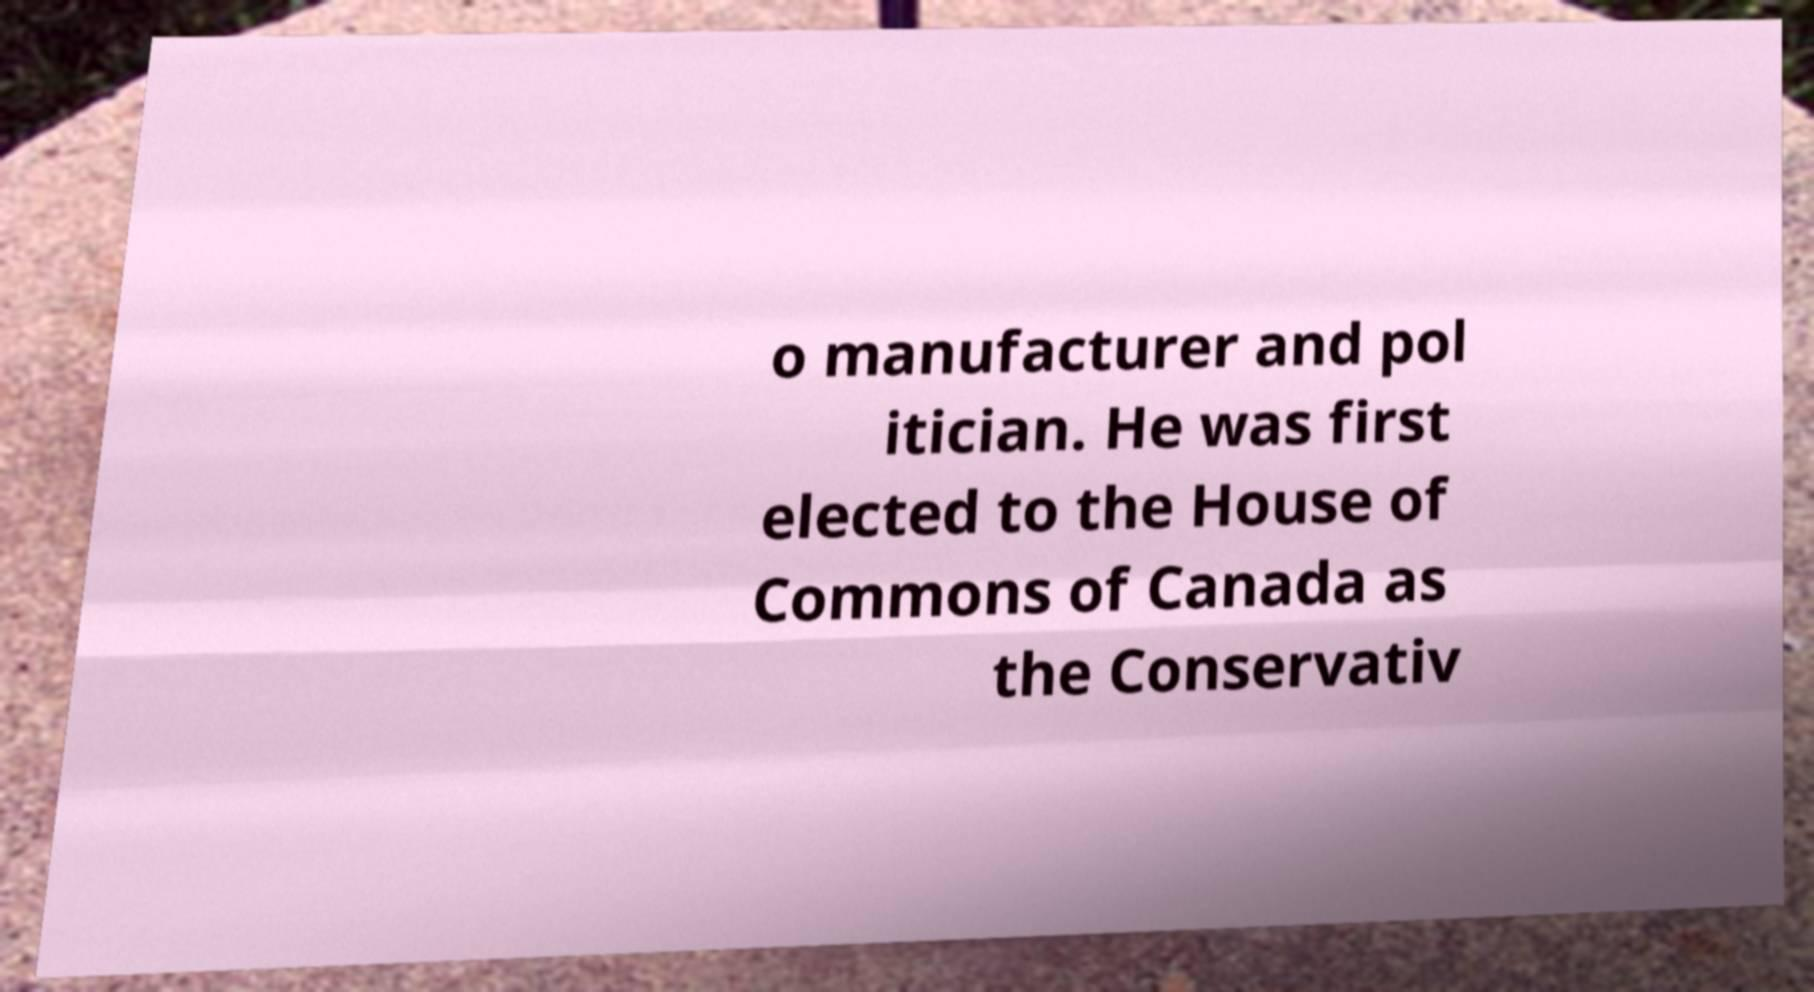Could you extract and type out the text from this image? o manufacturer and pol itician. He was first elected to the House of Commons of Canada as the Conservativ 